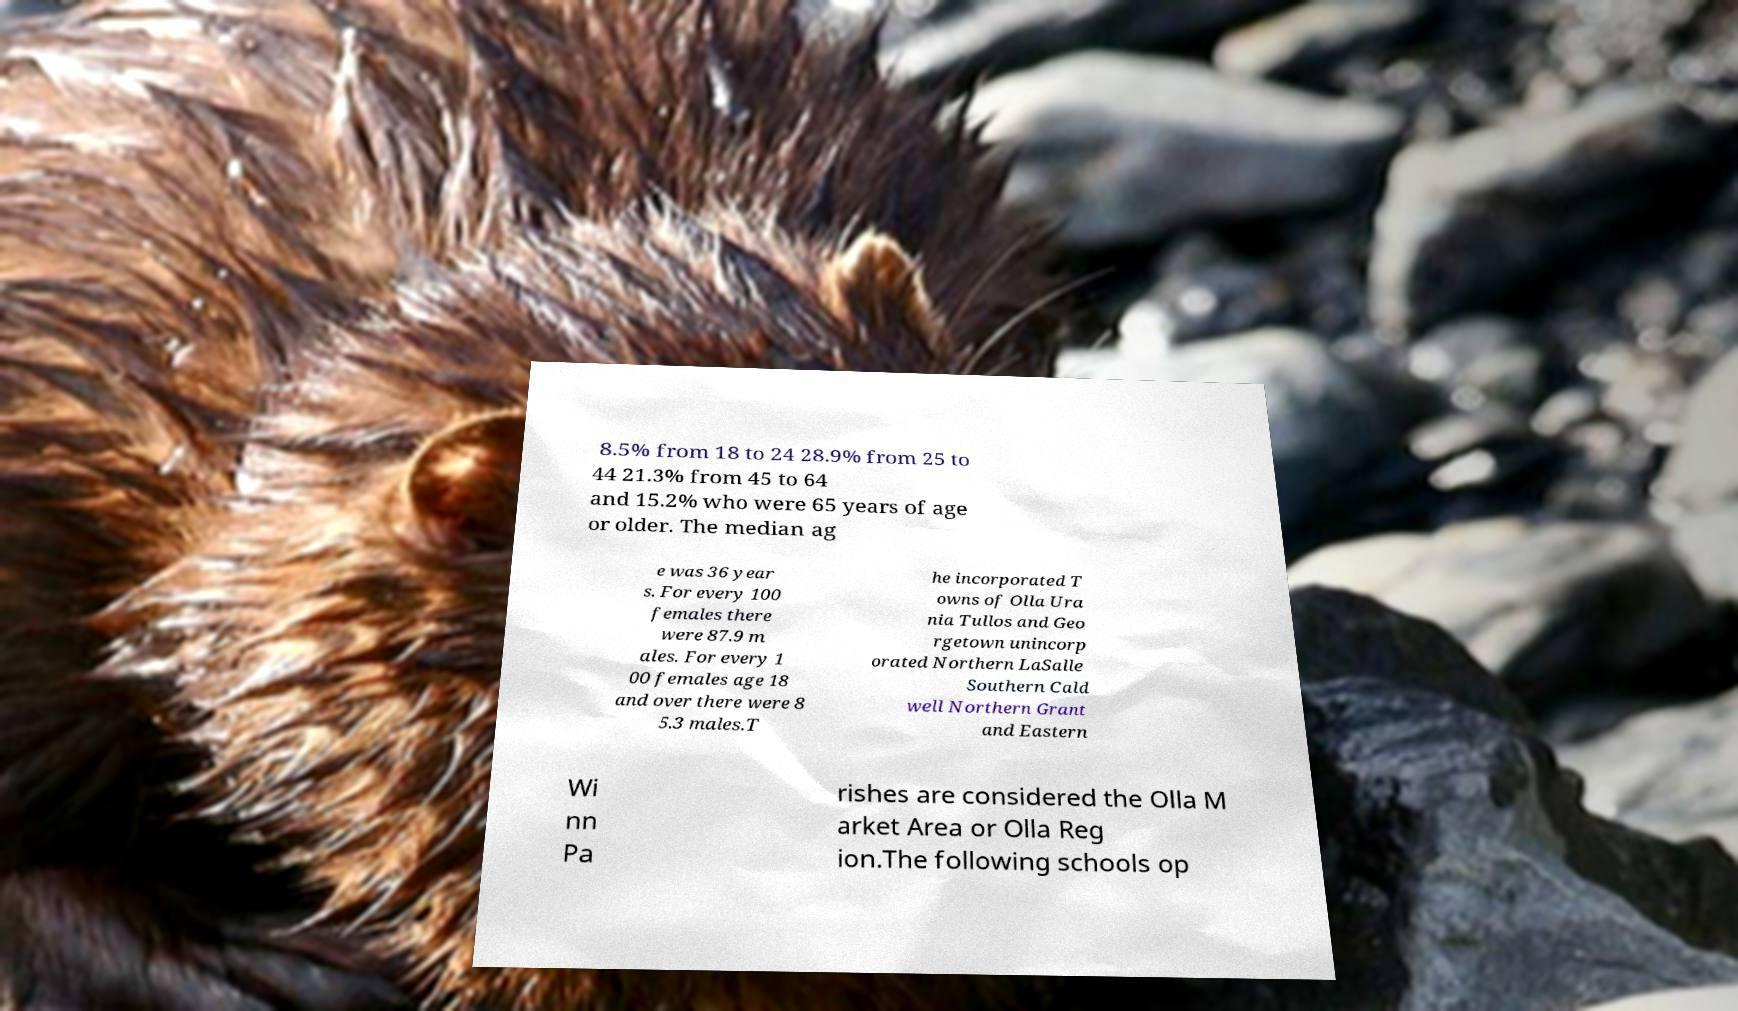There's text embedded in this image that I need extracted. Can you transcribe it verbatim? 8.5% from 18 to 24 28.9% from 25 to 44 21.3% from 45 to 64 and 15.2% who were 65 years of age or older. The median ag e was 36 year s. For every 100 females there were 87.9 m ales. For every 1 00 females age 18 and over there were 8 5.3 males.T he incorporated T owns of Olla Ura nia Tullos and Geo rgetown unincorp orated Northern LaSalle Southern Cald well Northern Grant and Eastern Wi nn Pa rishes are considered the Olla M arket Area or Olla Reg ion.The following schools op 